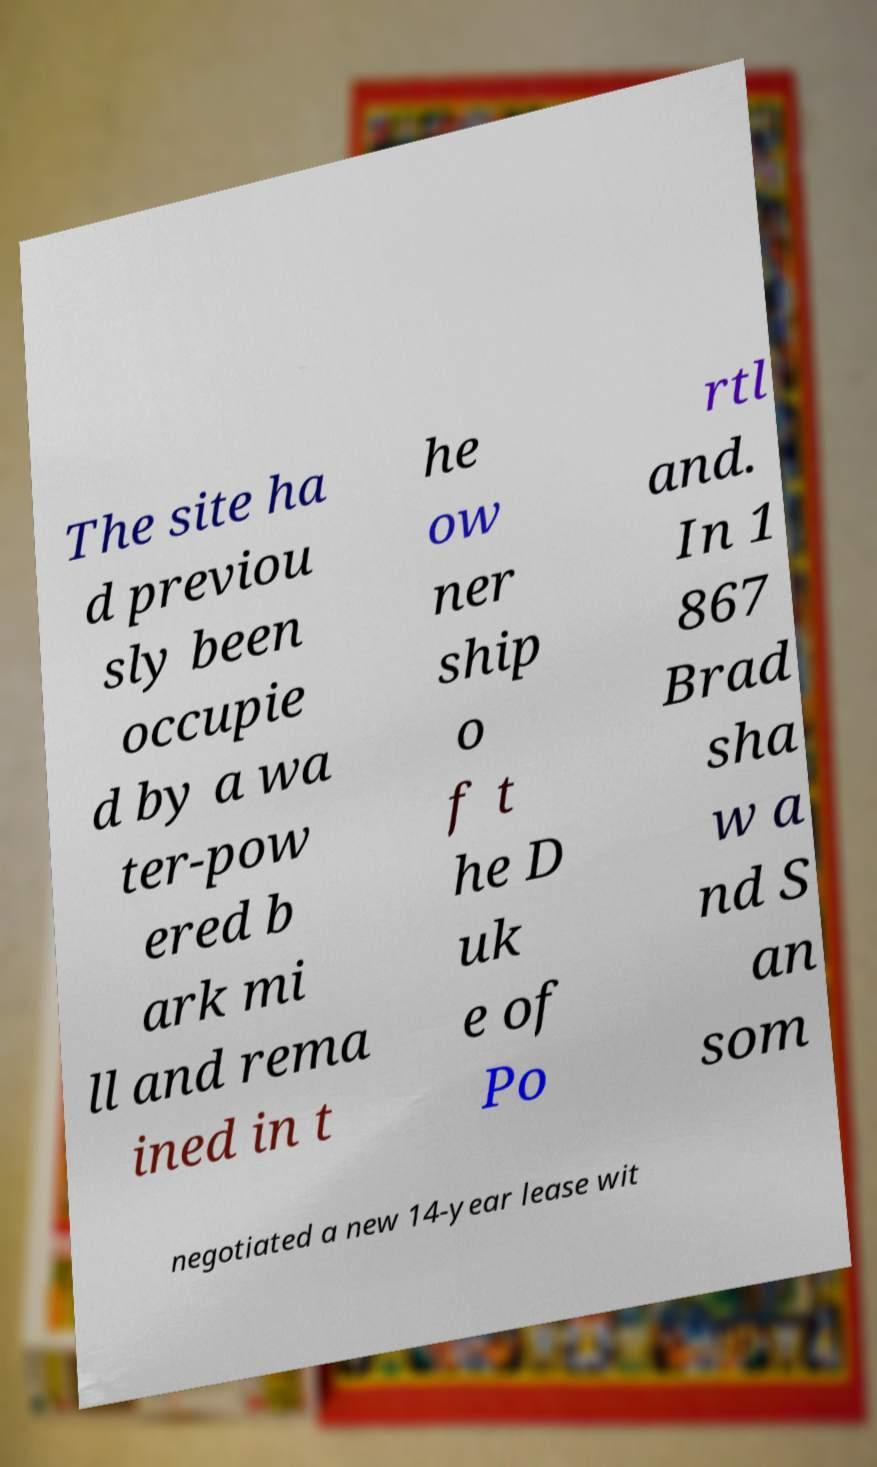Could you extract and type out the text from this image? The site ha d previou sly been occupie d by a wa ter-pow ered b ark mi ll and rema ined in t he ow ner ship o f t he D uk e of Po rtl and. In 1 867 Brad sha w a nd S an som negotiated a new 14-year lease wit 